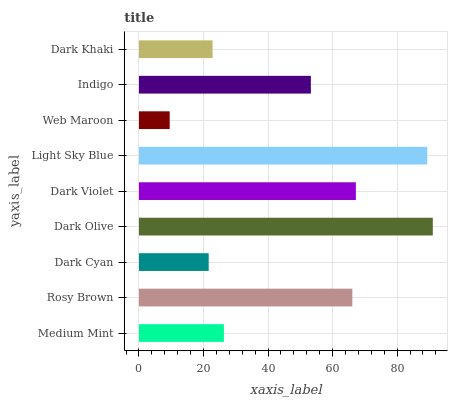Is Web Maroon the minimum?
Answer yes or no. Yes. Is Dark Olive the maximum?
Answer yes or no. Yes. Is Rosy Brown the minimum?
Answer yes or no. No. Is Rosy Brown the maximum?
Answer yes or no. No. Is Rosy Brown greater than Medium Mint?
Answer yes or no. Yes. Is Medium Mint less than Rosy Brown?
Answer yes or no. Yes. Is Medium Mint greater than Rosy Brown?
Answer yes or no. No. Is Rosy Brown less than Medium Mint?
Answer yes or no. No. Is Indigo the high median?
Answer yes or no. Yes. Is Indigo the low median?
Answer yes or no. Yes. Is Rosy Brown the high median?
Answer yes or no. No. Is Rosy Brown the low median?
Answer yes or no. No. 